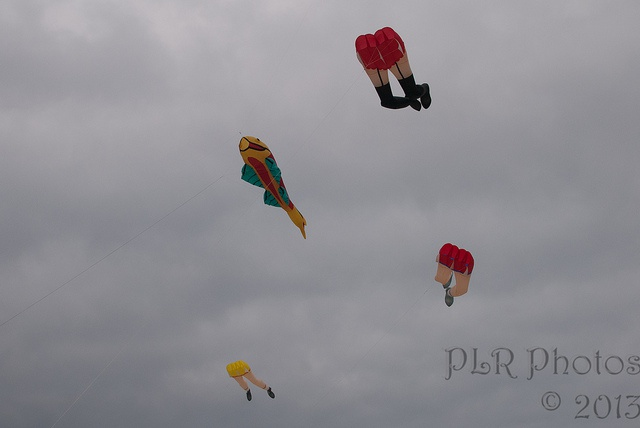Describe the objects in this image and their specific colors. I can see kite in darkgray, maroon, black, and brown tones, kite in darkgray, maroon, black, and teal tones, kite in darkgray, maroon, brown, and gray tones, and kite in darkgray, gray, and olive tones in this image. 